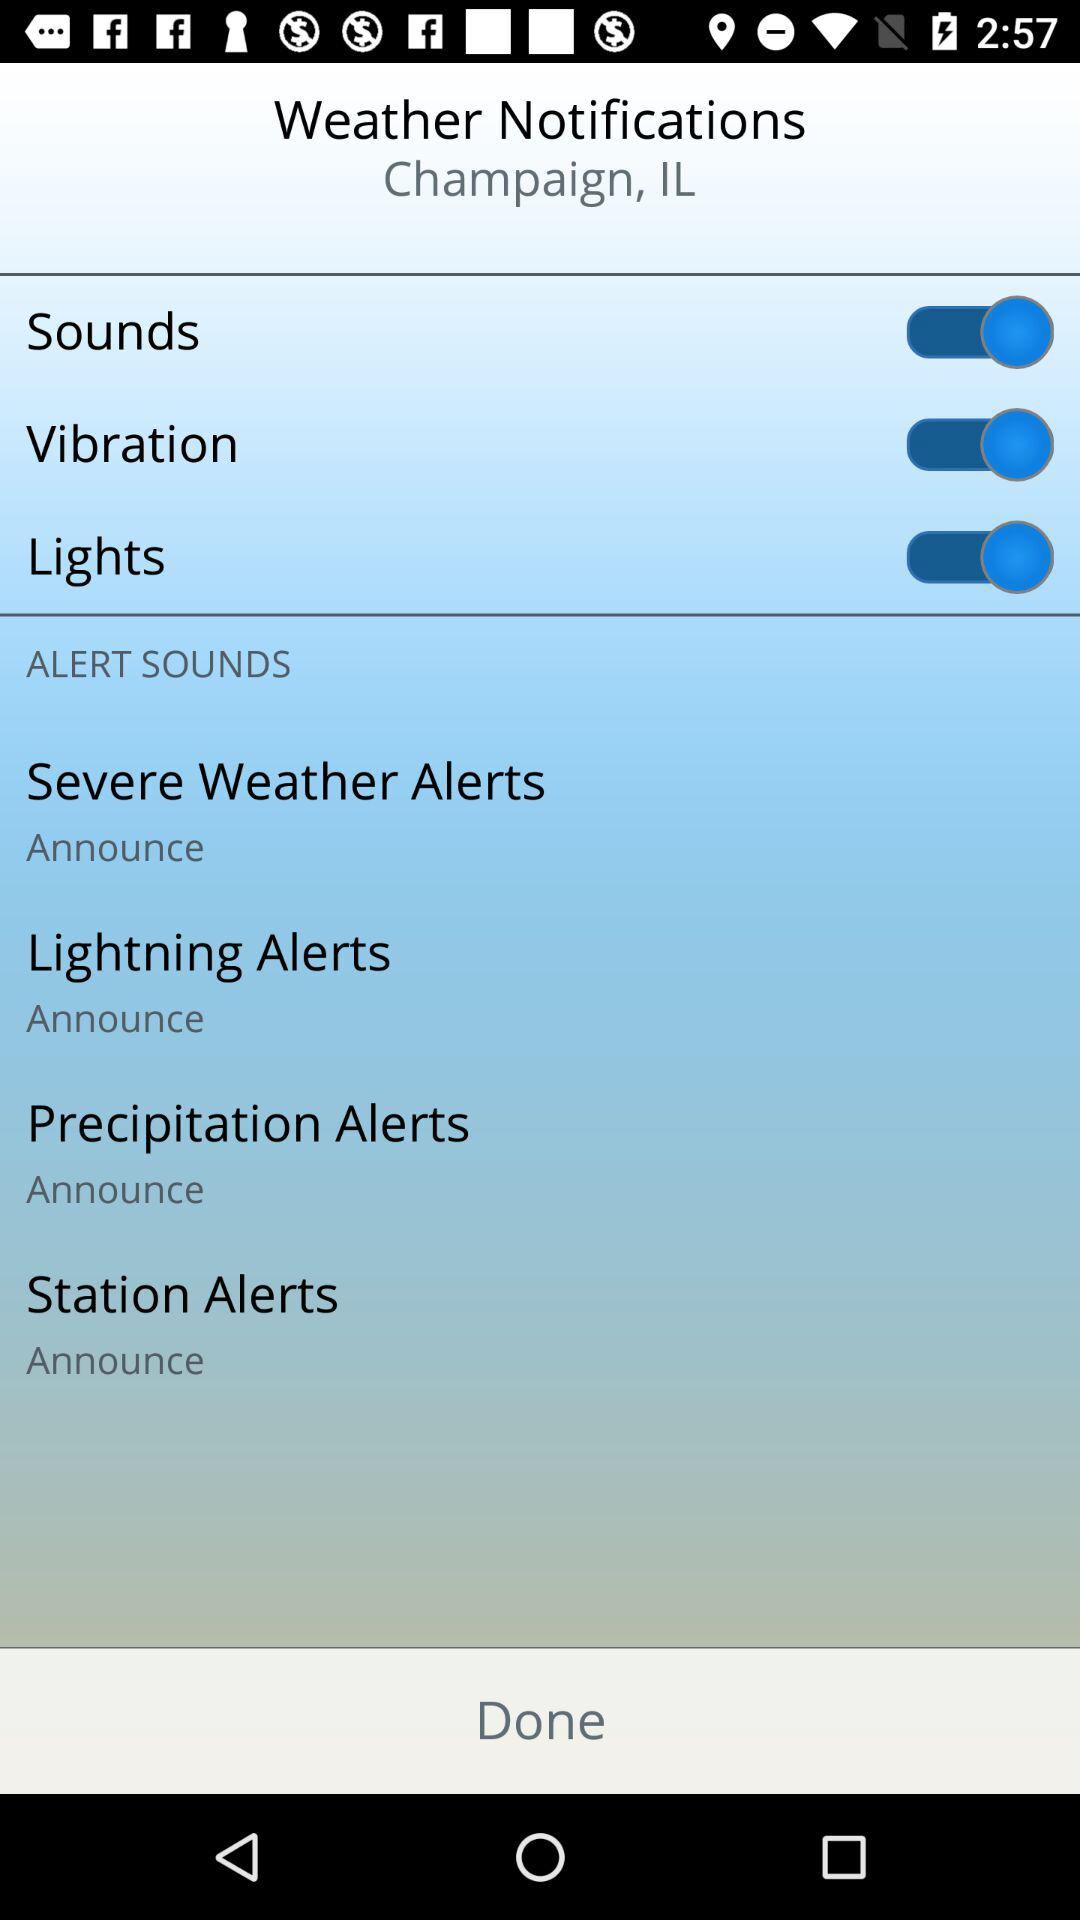What is the status of the vibration? The status is "on". 